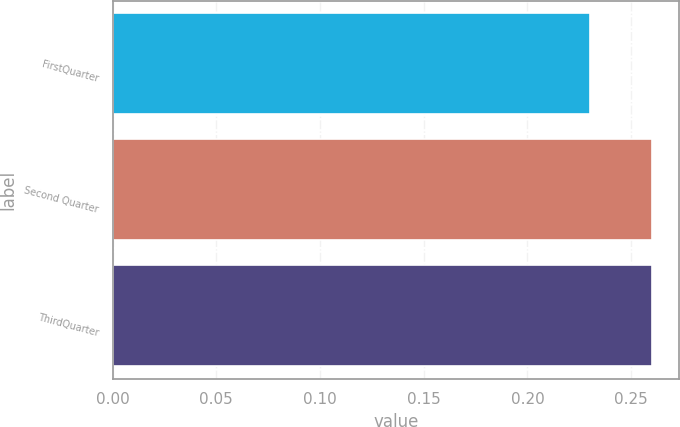Convert chart to OTSL. <chart><loc_0><loc_0><loc_500><loc_500><bar_chart><fcel>FirstQuarter<fcel>Second Quarter<fcel>ThirdQuarter<nl><fcel>0.23<fcel>0.26<fcel>0.26<nl></chart> 